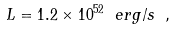<formula> <loc_0><loc_0><loc_500><loc_500>L = 1 . 2 \times 1 0 ^ { 5 2 } \ e r g / s \ ,</formula> 